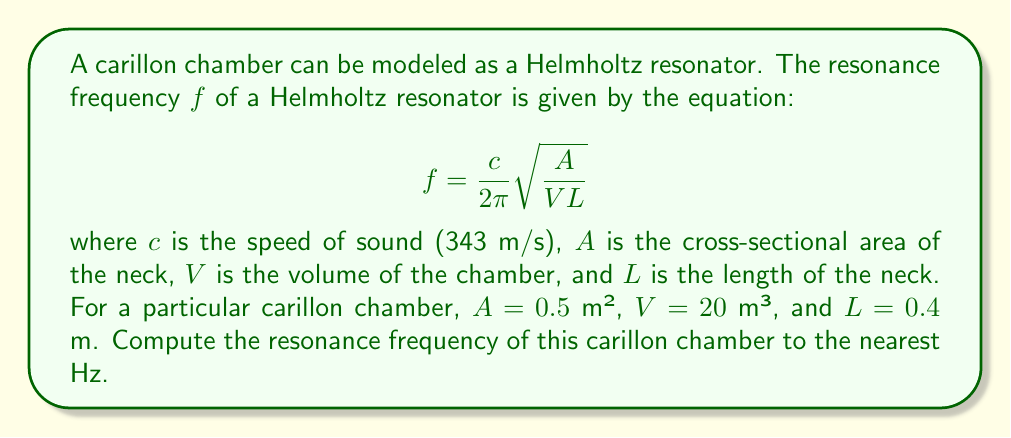Give your solution to this math problem. To solve this problem, we'll follow these steps:

1) We're given the equation for the resonance frequency of a Helmholtz resonator:

   $$f = \frac{c}{2\pi} \sqrt{\frac{A}{VL}}$$

2) We're also given the following values:
   - $c = 343$ m/s (speed of sound)
   - $A = 0.5$ m² (cross-sectional area of the neck)
   - $V = 20$ m³ (volume of the chamber)
   - $L = 0.4$ m (length of the neck)

3) Let's substitute these values into the equation:

   $$f = \frac{343}{2\pi} \sqrt{\frac{0.5}{20 \cdot 0.4}}$$

4) Simplify inside the square root:

   $$f = \frac{343}{2\pi} \sqrt{\frac{0.5}{8}}$$

5) Calculate the value under the square root:

   $$f = \frac{343}{2\pi} \sqrt{0.0625}$$

6) Take the square root:

   $$f = \frac{343}{2\pi} \cdot 0.25$$

7) Multiply:

   $$f = \frac{85.75}{\pi}$$

8) Divide:

   $$f \approx 27.29 \text{ Hz}$$

9) Rounding to the nearest Hz:

   $$f \approx 27 \text{ Hz}$$
Answer: 27 Hz 